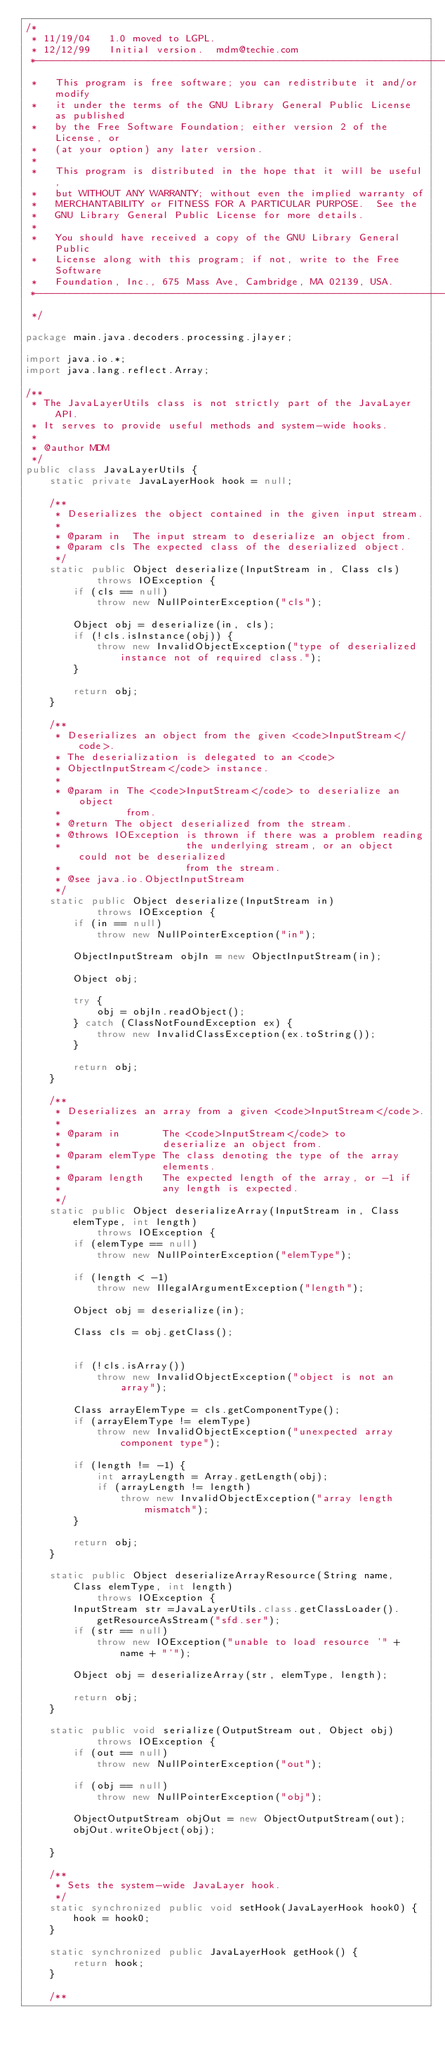Convert code to text. <code><loc_0><loc_0><loc_500><loc_500><_Java_>/*
 * 11/19/04		1.0 moved to LGPL.
 * 12/12/99		Initial version.	mdm@techie.com
 *-----------------------------------------------------------------------
 *   This program is free software; you can redistribute it and/or modify
 *   it under the terms of the GNU Library General Public License as published
 *   by the Free Software Foundation; either version 2 of the License, or
 *   (at your option) any later version.
 *
 *   This program is distributed in the hope that it will be useful,
 *   but WITHOUT ANY WARRANTY; without even the implied warranty of
 *   MERCHANTABILITY or FITNESS FOR A PARTICULAR PURPOSE.  See the
 *   GNU Library General Public License for more details.
 *
 *   You should have received a copy of the GNU Library General Public
 *   License along with this program; if not, write to the Free Software
 *   Foundation, Inc., 675 Mass Ave, Cambridge, MA 02139, USA.
 *----------------------------------------------------------------------
 */

package main.java.decoders.processing.jlayer;

import java.io.*;
import java.lang.reflect.Array;

/**
 * The JavaLayerUtils class is not strictly part of the JavaLayer API.
 * It serves to provide useful methods and system-wide hooks.
 *
 * @author MDM
 */
public class JavaLayerUtils {
    static private JavaLayerHook hook = null;

    /**
     * Deserializes the object contained in the given input stream.
     *
     * @param in  The input stream to deserialize an object from.
     * @param cls The expected class of the deserialized object.
     */
    static public Object deserialize(InputStream in, Class cls)
            throws IOException {
        if (cls == null)
            throw new NullPointerException("cls");

        Object obj = deserialize(in, cls);
        if (!cls.isInstance(obj)) {
            throw new InvalidObjectException("type of deserialized instance not of required class.");
        }

        return obj;
    }

    /**
     * Deserializes an object from the given <code>InputStream</code>.
     * The deserialization is delegated to an <code>
     * ObjectInputStream</code> instance.
     *
     * @param in The <code>InputStream</code> to deserialize an object
     *           from.
     * @return The object deserialized from the stream.
     * @throws IOException is thrown if there was a problem reading
     *                     the underlying stream, or an object could not be deserialized
     *                     from the stream.
     * @see java.io.ObjectInputStream
     */
    static public Object deserialize(InputStream in)
            throws IOException {
        if (in == null)
            throw new NullPointerException("in");

        ObjectInputStream objIn = new ObjectInputStream(in);

        Object obj;

        try {
            obj = objIn.readObject();
        } catch (ClassNotFoundException ex) {
            throw new InvalidClassException(ex.toString());
        }

        return obj;
    }

    /**
     * Deserializes an array from a given <code>InputStream</code>.
     *
     * @param in       The <code>InputStream</code> to
     *                 deserialize an object from.
     * @param elemType The class denoting the type of the array
     *                 elements.
     * @param length   The expected length of the array, or -1 if
     *                 any length is expected.
     */
    static public Object deserializeArray(InputStream in, Class elemType, int length)
            throws IOException {
        if (elemType == null)
            throw new NullPointerException("elemType");

        if (length < -1)
            throw new IllegalArgumentException("length");

        Object obj = deserialize(in);

        Class cls = obj.getClass();


        if (!cls.isArray())
            throw new InvalidObjectException("object is not an array");

        Class arrayElemType = cls.getComponentType();
        if (arrayElemType != elemType)
            throw new InvalidObjectException("unexpected array component type");

        if (length != -1) {
            int arrayLength = Array.getLength(obj);
            if (arrayLength != length)
                throw new InvalidObjectException("array length mismatch");
        }

        return obj;
    }

    static public Object deserializeArrayResource(String name, Class elemType, int length)
            throws IOException {
        InputStream str =JavaLayerUtils.class.getClassLoader().getResourceAsStream("sfd.ser");
        if (str == null)
            throw new IOException("unable to load resource '" + name + "'");

        Object obj = deserializeArray(str, elemType, length);

        return obj;
    }

    static public void serialize(OutputStream out, Object obj)
            throws IOException {
        if (out == null)
            throw new NullPointerException("out");

        if (obj == null)
            throw new NullPointerException("obj");

        ObjectOutputStream objOut = new ObjectOutputStream(out);
        objOut.writeObject(obj);

    }

    /**
     * Sets the system-wide JavaLayer hook.
     */
    static synchronized public void setHook(JavaLayerHook hook0) {
        hook = hook0;
    }

    static synchronized public JavaLayerHook getHook() {
        return hook;
    }

    /**</code> 